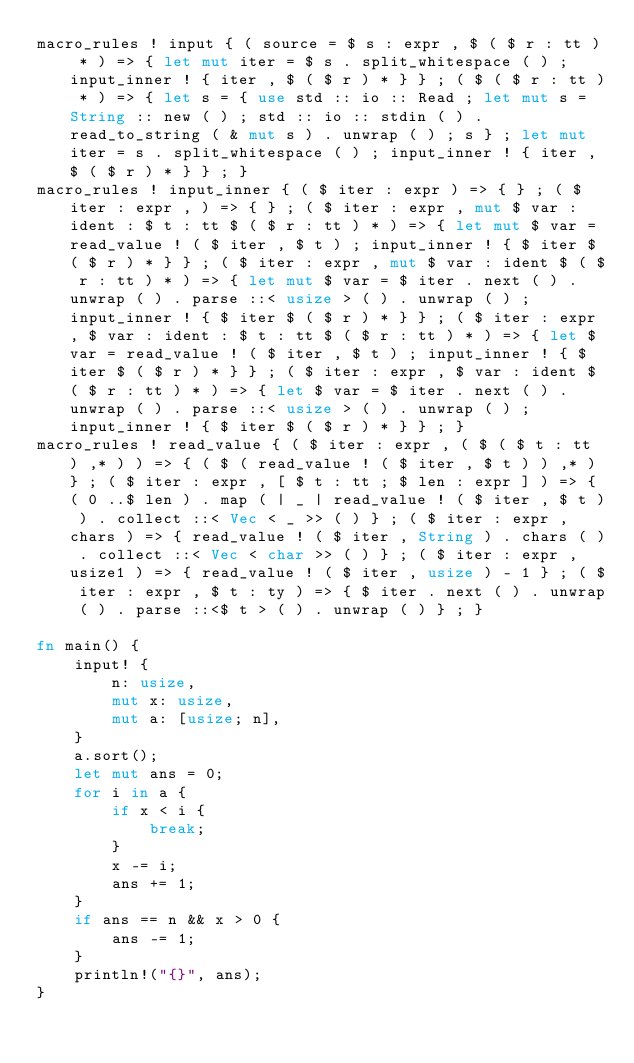Convert code to text. <code><loc_0><loc_0><loc_500><loc_500><_Rust_>macro_rules ! input { ( source = $ s : expr , $ ( $ r : tt ) * ) => { let mut iter = $ s . split_whitespace ( ) ; input_inner ! { iter , $ ( $ r ) * } } ; ( $ ( $ r : tt ) * ) => { let s = { use std :: io :: Read ; let mut s = String :: new ( ) ; std :: io :: stdin ( ) . read_to_string ( & mut s ) . unwrap ( ) ; s } ; let mut iter = s . split_whitespace ( ) ; input_inner ! { iter , $ ( $ r ) * } } ; }
macro_rules ! input_inner { ( $ iter : expr ) => { } ; ( $ iter : expr , ) => { } ; ( $ iter : expr , mut $ var : ident : $ t : tt $ ( $ r : tt ) * ) => { let mut $ var = read_value ! ( $ iter , $ t ) ; input_inner ! { $ iter $ ( $ r ) * } } ; ( $ iter : expr , mut $ var : ident $ ( $ r : tt ) * ) => { let mut $ var = $ iter . next ( ) . unwrap ( ) . parse ::< usize > ( ) . unwrap ( ) ; input_inner ! { $ iter $ ( $ r ) * } } ; ( $ iter : expr , $ var : ident : $ t : tt $ ( $ r : tt ) * ) => { let $ var = read_value ! ( $ iter , $ t ) ; input_inner ! { $ iter $ ( $ r ) * } } ; ( $ iter : expr , $ var : ident $ ( $ r : tt ) * ) => { let $ var = $ iter . next ( ) . unwrap ( ) . parse ::< usize > ( ) . unwrap ( ) ; input_inner ! { $ iter $ ( $ r ) * } } ; }
macro_rules ! read_value { ( $ iter : expr , ( $ ( $ t : tt ) ,* ) ) => { ( $ ( read_value ! ( $ iter , $ t ) ) ,* ) } ; ( $ iter : expr , [ $ t : tt ; $ len : expr ] ) => { ( 0 ..$ len ) . map ( | _ | read_value ! ( $ iter , $ t ) ) . collect ::< Vec < _ >> ( ) } ; ( $ iter : expr , chars ) => { read_value ! ( $ iter , String ) . chars ( ) . collect ::< Vec < char >> ( ) } ; ( $ iter : expr , usize1 ) => { read_value ! ( $ iter , usize ) - 1 } ; ( $ iter : expr , $ t : ty ) => { $ iter . next ( ) . unwrap ( ) . parse ::<$ t > ( ) . unwrap ( ) } ; }

fn main() {
    input! {
        n: usize,
        mut x: usize,
        mut a: [usize; n],
    }
    a.sort();
    let mut ans = 0;
    for i in a {
        if x < i {
            break;
        }
        x -= i;
        ans += 1;
    }
    if ans == n && x > 0 {
        ans -= 1;
    }
    println!("{}", ans);
}
</code> 